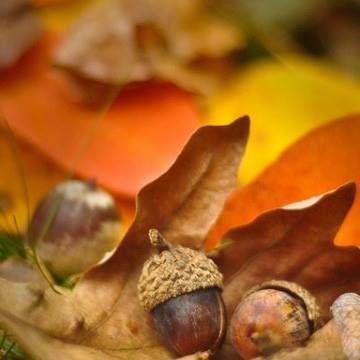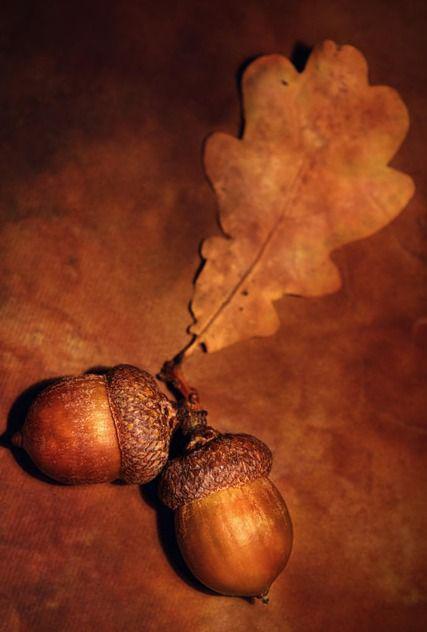The first image is the image on the left, the second image is the image on the right. Examine the images to the left and right. Is the description "The acorns in one of the images are green, while the acorns in the other image are brown." accurate? Answer yes or no. No. The first image is the image on the left, the second image is the image on the right. Analyze the images presented: Is the assertion "There are five real acorns." valid? Answer yes or no. Yes. 